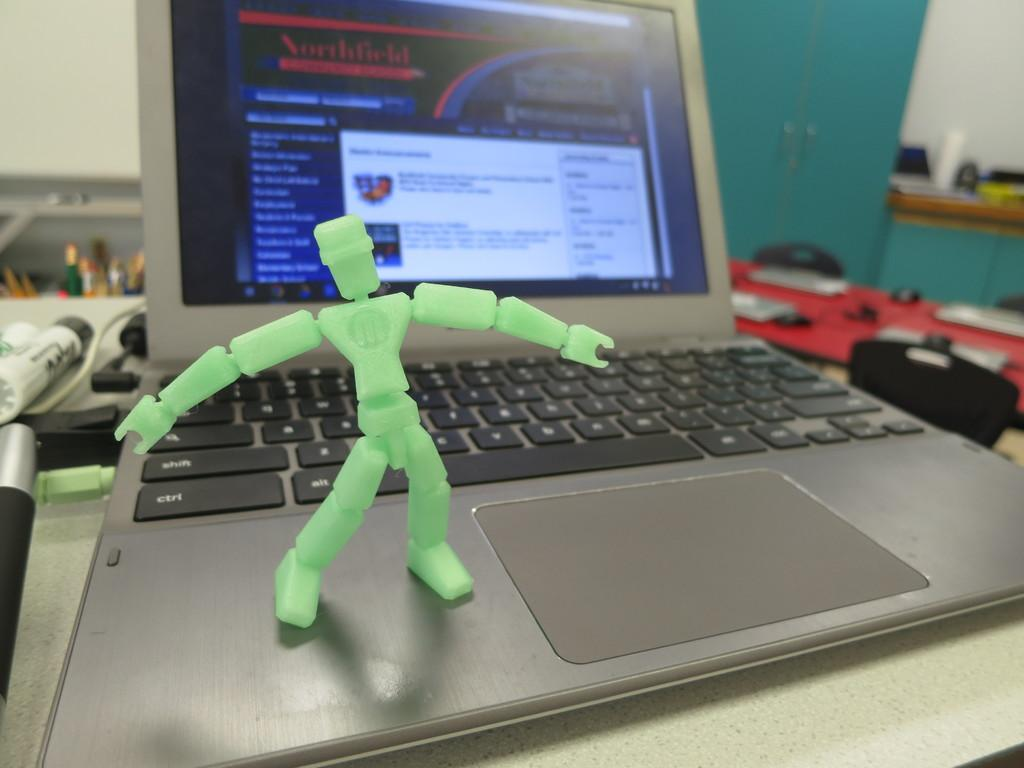<image>
Create a compact narrative representing the image presented. A laptop with a shift keyboard button behind a green figure. 